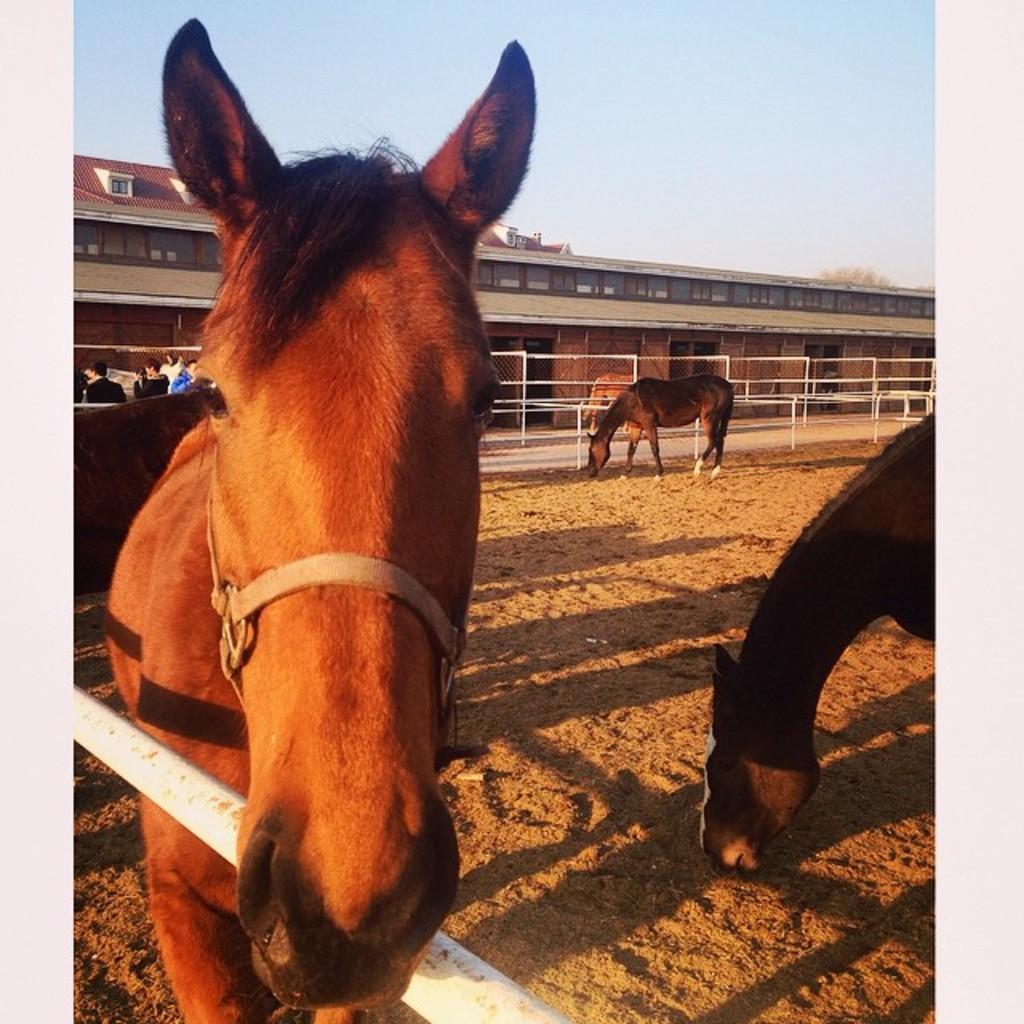How would you summarize this image in a sentence or two? In this picture there is a horse who is standing near to the fencing. On the right there are two horse who are eating something from the ground. In the background I can see some people were standing near to the fencing. And beside them there is a building. At the top I can see the sky. In the top right there is a tree. 